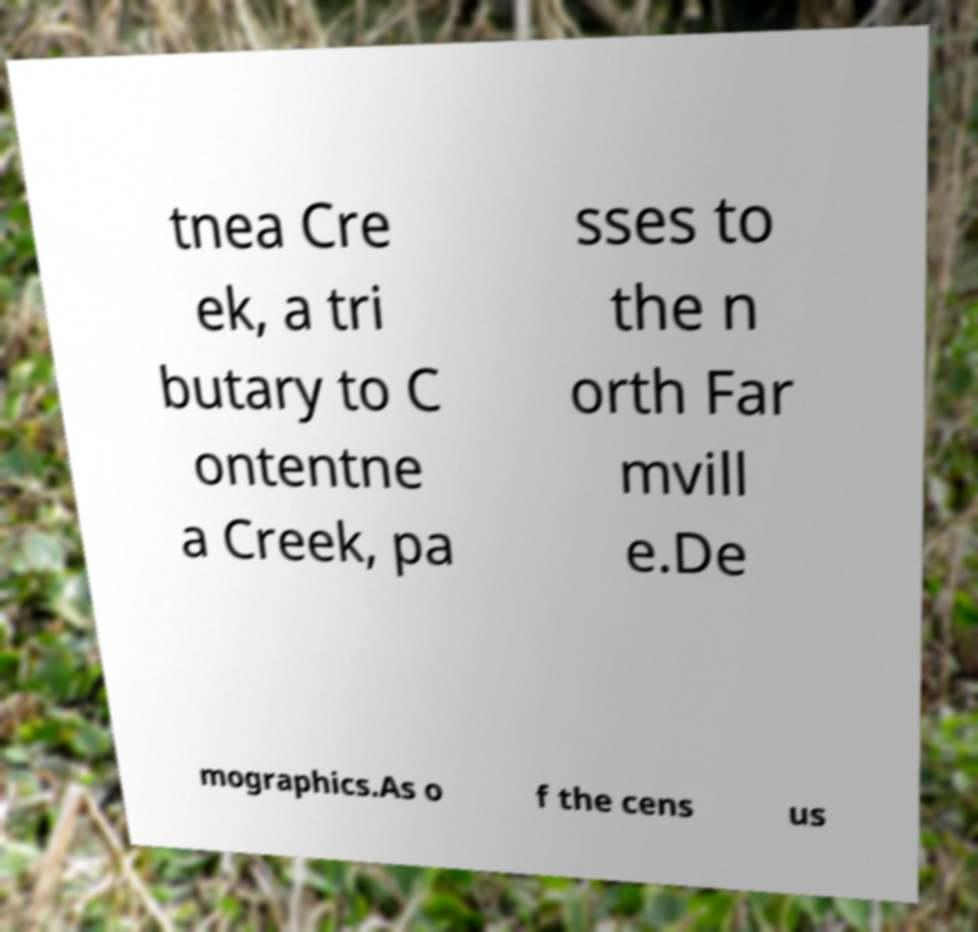What messages or text are displayed in this image? I need them in a readable, typed format. tnea Cre ek, a tri butary to C ontentne a Creek, pa sses to the n orth Far mvill e.De mographics.As o f the cens us 